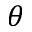<formula> <loc_0><loc_0><loc_500><loc_500>\theta</formula> 